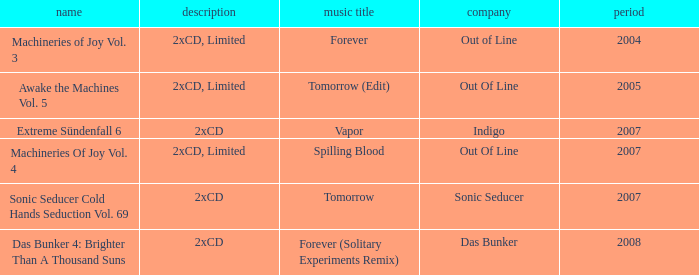Which track title has a year lesser thsn 2005? Forever. 